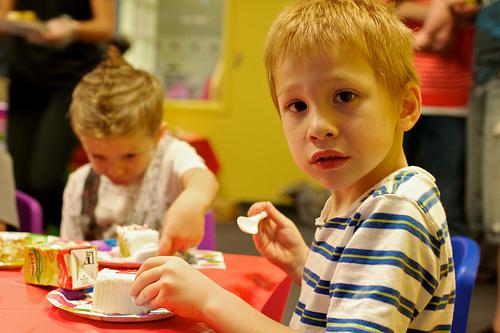Question: how many children are there?
Choices:
A. 2.
B. 3.
C. 4.
D. 5.
Answer with the letter. Answer: A Question: what are they doing?
Choices:
A. Drinking.
B. Eating.
C. Dancing.
D. Talking.
Answer with the letter. Answer: B Question: what is the color of the table?
Choices:
A. Black.
B. Red.
C. Brown.
D. Green.
Answer with the letter. Answer: B Question: what is the boy having in his hand?
Choices:
A. Forks.
B. Spoon.
C. Knives.
D. Pens.
Answer with the letter. Answer: B Question: what color spoon is that?
Choices:
A. Black.
B. White.
C. Gray.
D. Brown.
Answer with the letter. Answer: B Question: where is the photo taken?
Choices:
A. At school.
B. In a church.
C. In a library.
D. On a mountain.
Answer with the letter. Answer: A 